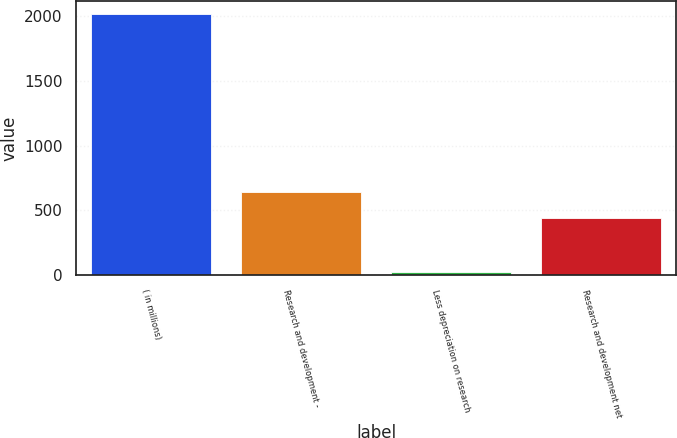Convert chart. <chart><loc_0><loc_0><loc_500><loc_500><bar_chart><fcel>( in millions)<fcel>Research and development -<fcel>Less depreciation on research<fcel>Research and development net<nl><fcel>2018<fcel>640.5<fcel>23<fcel>441<nl></chart> 